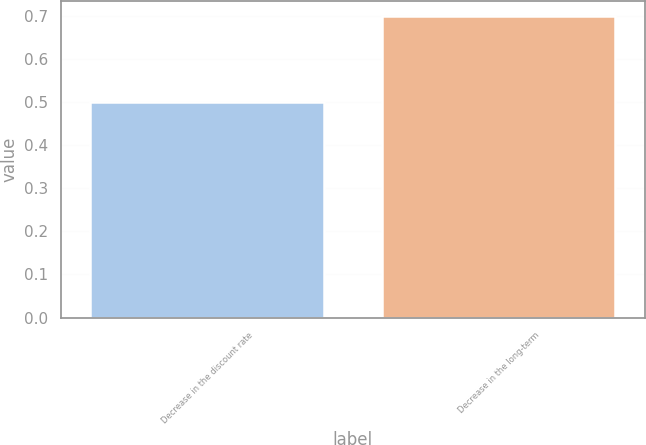Convert chart. <chart><loc_0><loc_0><loc_500><loc_500><bar_chart><fcel>Decrease in the discount rate<fcel>Decrease in the long-term<nl><fcel>0.5<fcel>0.7<nl></chart> 